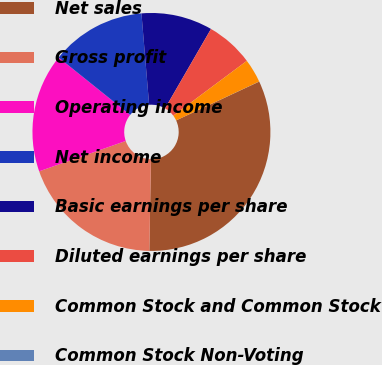Convert chart to OTSL. <chart><loc_0><loc_0><loc_500><loc_500><pie_chart><fcel>Net sales<fcel>Gross profit<fcel>Operating income<fcel>Net income<fcel>Basic earnings per share<fcel>Diluted earnings per share<fcel>Common Stock and Common Stock<fcel>Common Stock Non-Voting<nl><fcel>32.24%<fcel>19.35%<fcel>16.13%<fcel>12.9%<fcel>9.68%<fcel>6.46%<fcel>3.23%<fcel>0.01%<nl></chart> 